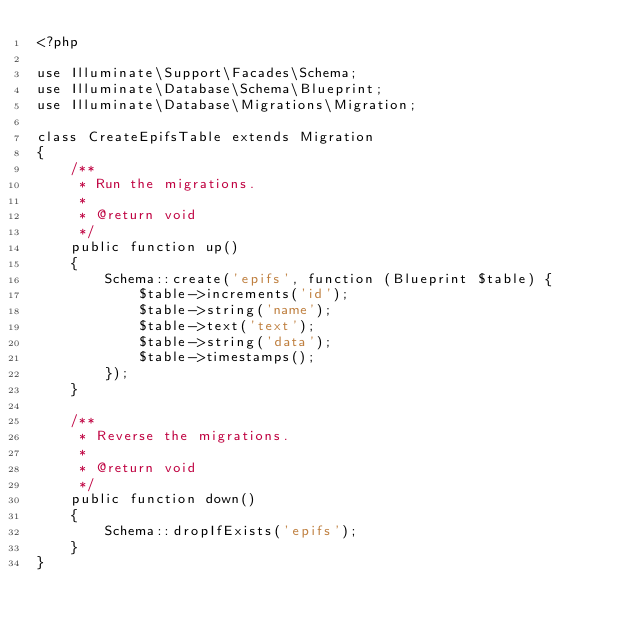Convert code to text. <code><loc_0><loc_0><loc_500><loc_500><_PHP_><?php

use Illuminate\Support\Facades\Schema;
use Illuminate\Database\Schema\Blueprint;
use Illuminate\Database\Migrations\Migration;

class CreateEpifsTable extends Migration
{
    /**
     * Run the migrations.
     *
     * @return void
     */
    public function up()
    {
        Schema::create('epifs', function (Blueprint $table) {
            $table->increments('id');
            $table->string('name');
            $table->text('text');
            $table->string('data');
            $table->timestamps();
        });
    }

    /**
     * Reverse the migrations.
     *
     * @return void
     */
    public function down()
    {
        Schema::dropIfExists('epifs');
    }
}
</code> 